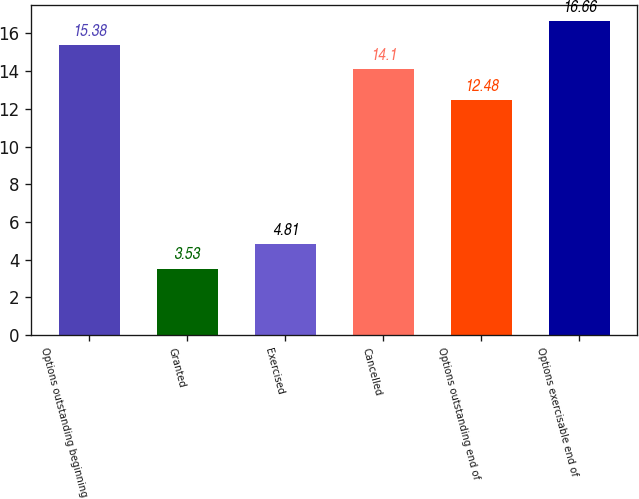Convert chart. <chart><loc_0><loc_0><loc_500><loc_500><bar_chart><fcel>Options outstanding beginning<fcel>Granted<fcel>Exercised<fcel>Cancelled<fcel>Options outstanding end of<fcel>Options exercisable end of<nl><fcel>15.38<fcel>3.53<fcel>4.81<fcel>14.1<fcel>12.48<fcel>16.66<nl></chart> 